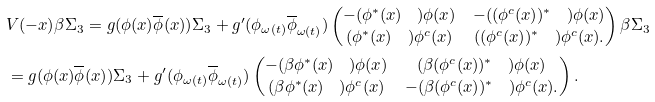<formula> <loc_0><loc_0><loc_500><loc_500>& V ( - x ) \beta \Sigma _ { 3 } = g ( \phi ( x ) \overline { \phi } ( x ) ) \Sigma _ { 3 } + g ^ { \prime } ( { \phi } _ { \omega ( t ) } \overline { \phi } _ { \omega ( t ) } ) \begin{pmatrix} - ( { \phi } ^ { * } ( x ) \quad ) \phi ( x ) & - ( ( \phi ^ { c } ( x ) ) ^ { * } \quad ) \phi ( x ) \\ ( \phi ^ { * } ( x ) { \quad } ) \phi ^ { c } ( x ) & ( ( \phi ^ { c } ( x ) ) ^ { * } \quad ) \phi ^ { c } ( x ) . \end{pmatrix} \beta \Sigma _ { 3 } \\ & = g ( \phi ( x ) \overline { \phi } ( x ) ) \Sigma _ { 3 } + g ^ { \prime } ( { \phi } _ { \omega ( t ) } \overline { \phi } _ { \omega ( t ) } ) \begin{pmatrix} - ( \beta { \phi } ^ { * } ( x ) \quad ) \phi ( x ) & ( \beta ( \phi ^ { c } ( x ) ) ^ { * } \quad ) \phi ( x ) \\ ( \beta \phi ^ { * } ( x ) { \quad } ) \phi ^ { c } ( x ) & - ( \beta ( \phi ^ { c } ( x ) ) ^ { * } \quad ) \phi ^ { c } ( x ) . \end{pmatrix} .</formula> 